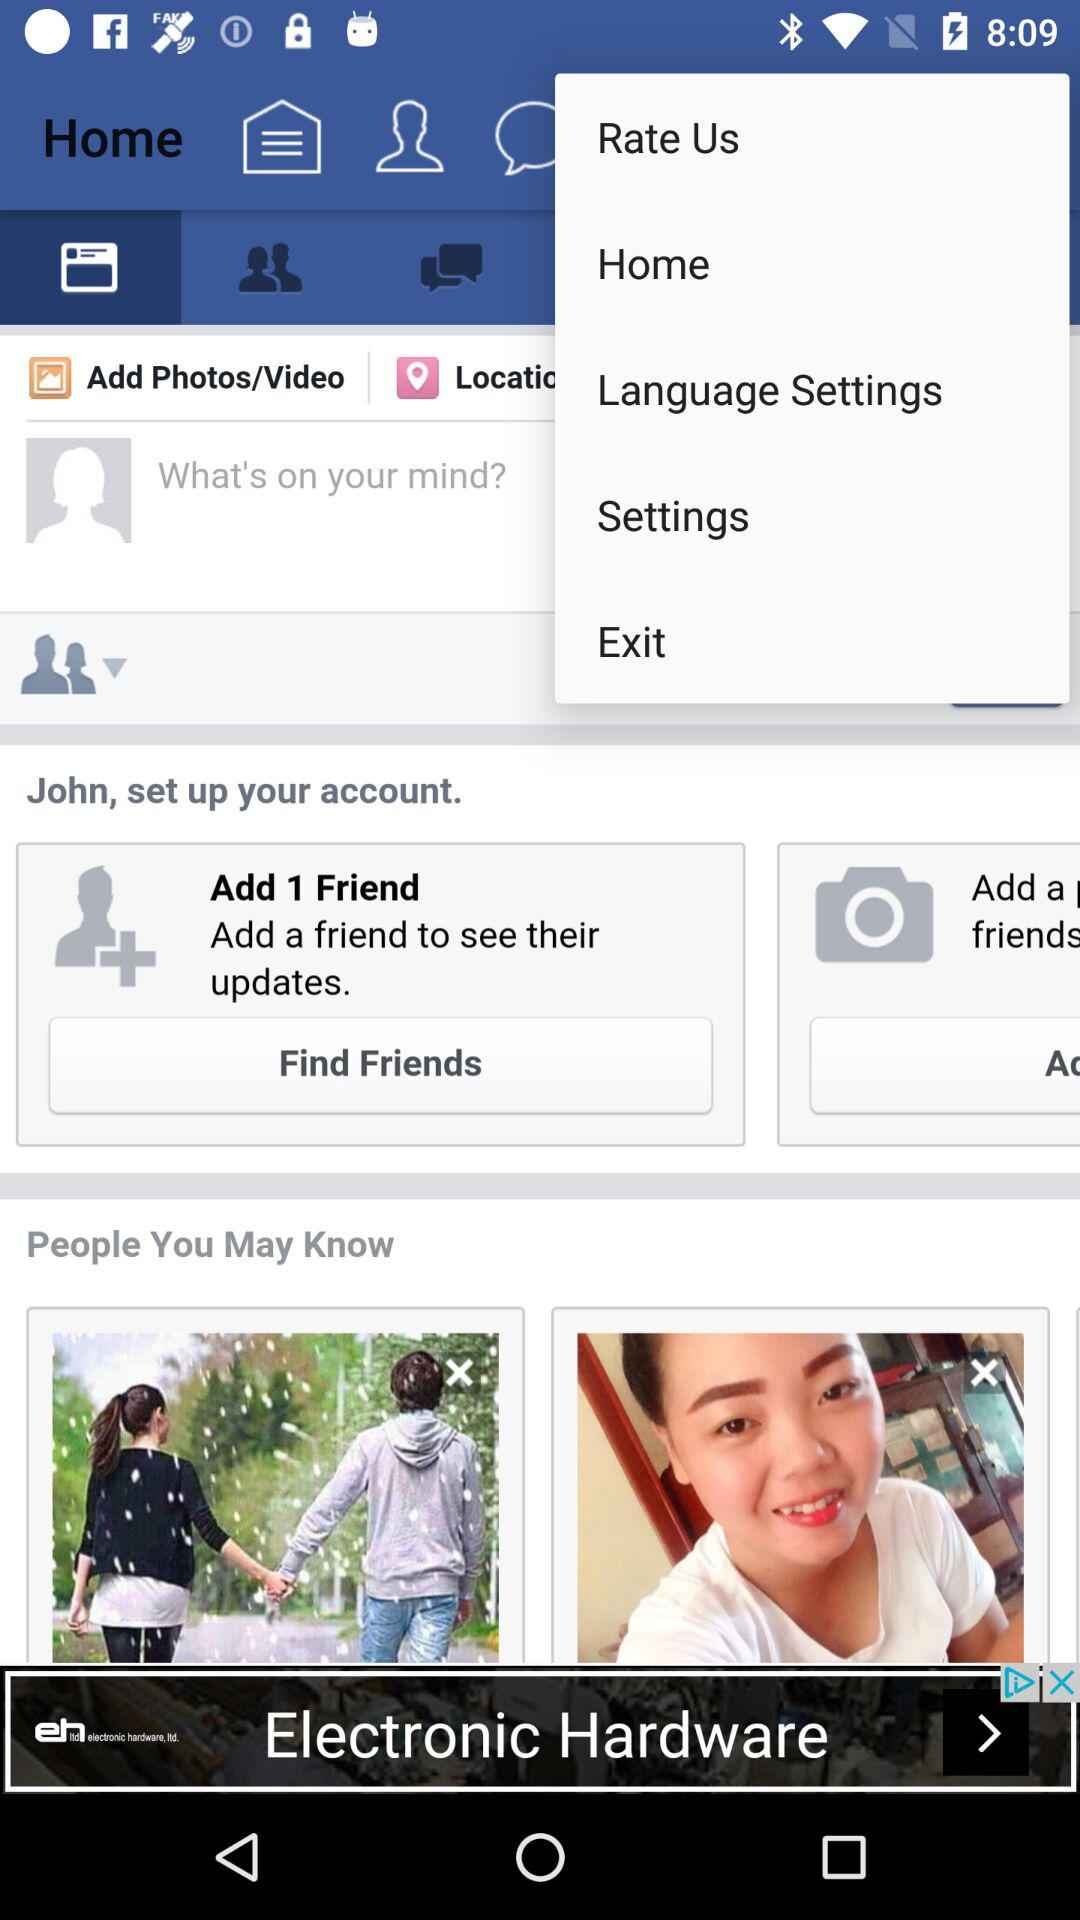What is the user name? The user name is John. 